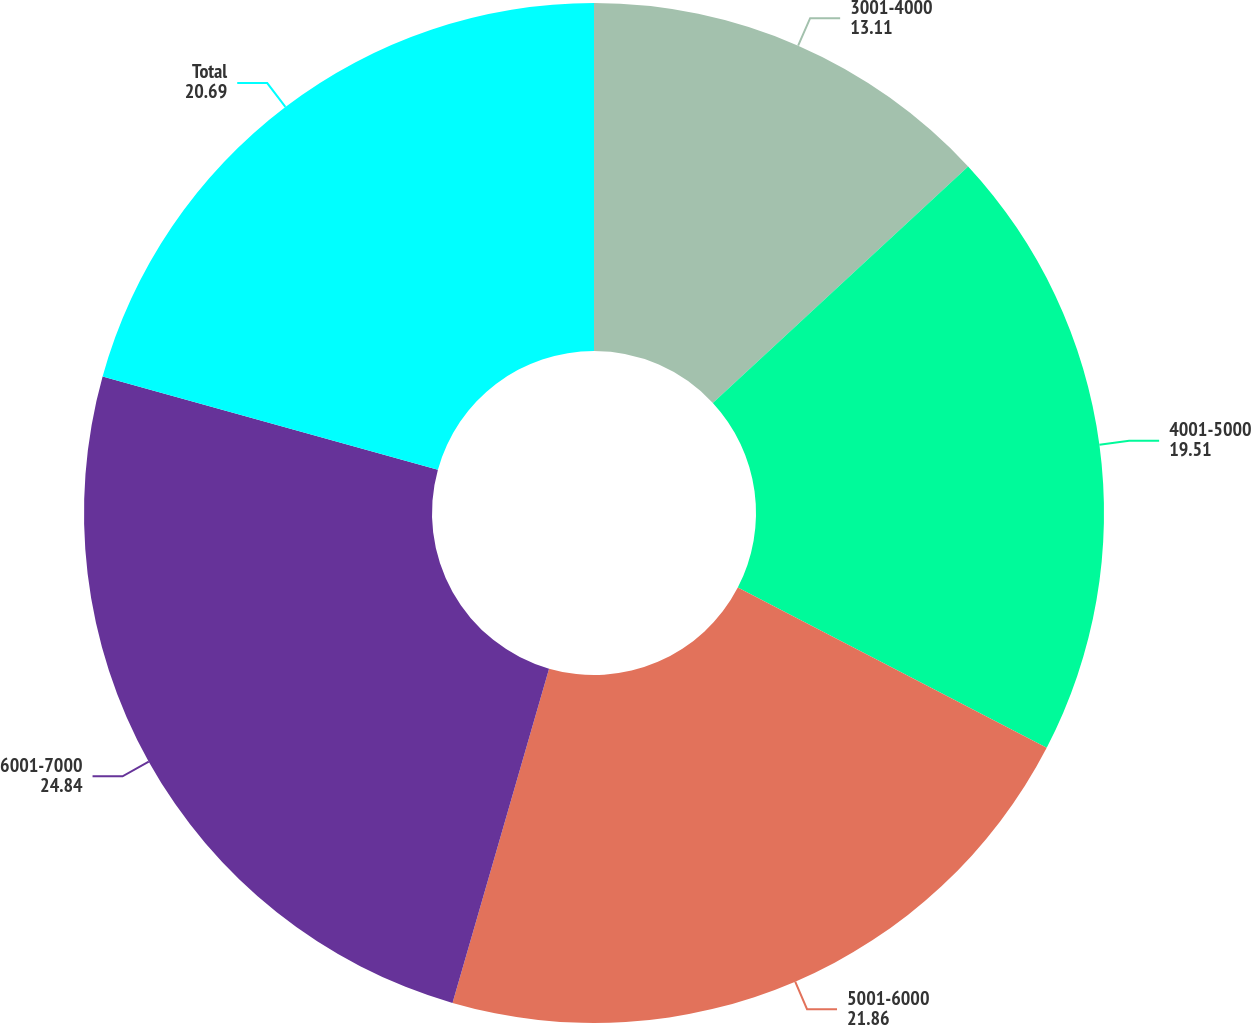Convert chart to OTSL. <chart><loc_0><loc_0><loc_500><loc_500><pie_chart><fcel>3001-4000<fcel>4001-5000<fcel>5001-6000<fcel>6001-7000<fcel>Total<nl><fcel>13.11%<fcel>19.51%<fcel>21.86%<fcel>24.84%<fcel>20.69%<nl></chart> 